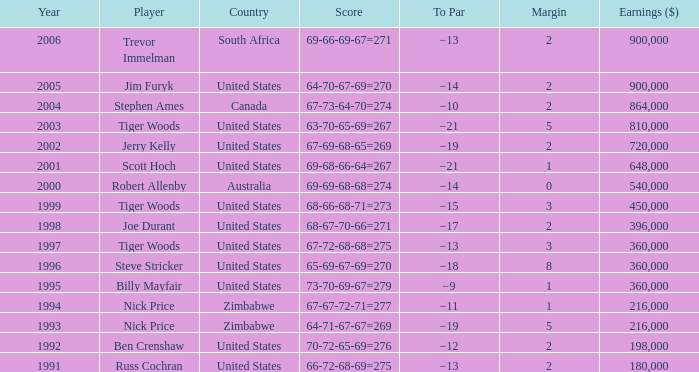What is canada's edge? 2.0. 